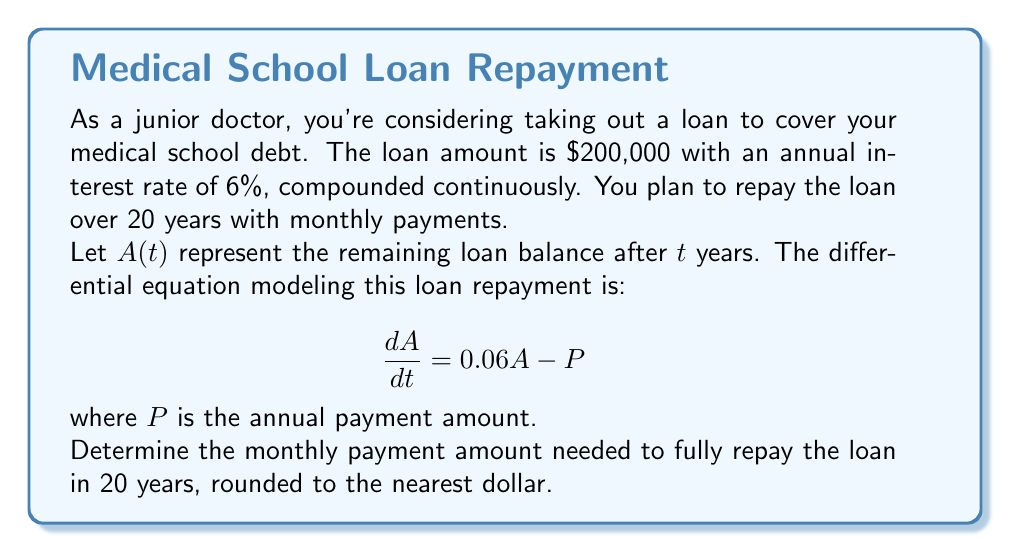Can you solve this math problem? Let's solve this step-by-step:

1) The general solution to this differential equation is:
   $$A(t) = Ce^{0.06t} + \frac{P}{0.06}$$

2) We know the initial condition: $A(0) = 200,000$. Substituting this:
   $$200,000 = C + \frac{P}{0.06}$$

3) We also know that after 20 years, the loan should be fully paid: $A(20) = 0$
   $$0 = Ce^{0.06(20)} + \frac{P}{0.06}$$

4) From step 2, we can express $C$ in terms of $P$:
   $$C = 200,000 - \frac{P}{0.06}$$

5) Substituting this into the equation from step 3:
   $$0 = (200,000 - \frac{P}{0.06})e^{1.2} + \frac{P}{0.06}$$

6) Simplifying:
   $$0 = 200,000e^{1.2} - \frac{P}{0.06}e^{1.2} + \frac{P}{0.06}$$
   $$\frac{P}{0.06}e^{1.2} - \frac{P}{0.06} = 200,000e^{1.2}$$
   $$P(\frac{e^{1.2}}{0.06} - \frac{1}{0.06}) = 200,000e^{1.2}$$

7) Solving for $P$:
   $$P = \frac{200,000e^{1.2}}{\frac{e^{1.2}}{0.06} - \frac{1}{0.06}} \approx 17,386.84$$

8) This is the annual payment. For monthly payments, divide by 12:
   $$\text{Monthly Payment} = \frac{17,386.84}{12} \approx 1,448.90$$

9) Rounding to the nearest dollar: $1,449
Answer: $1,449 per month 